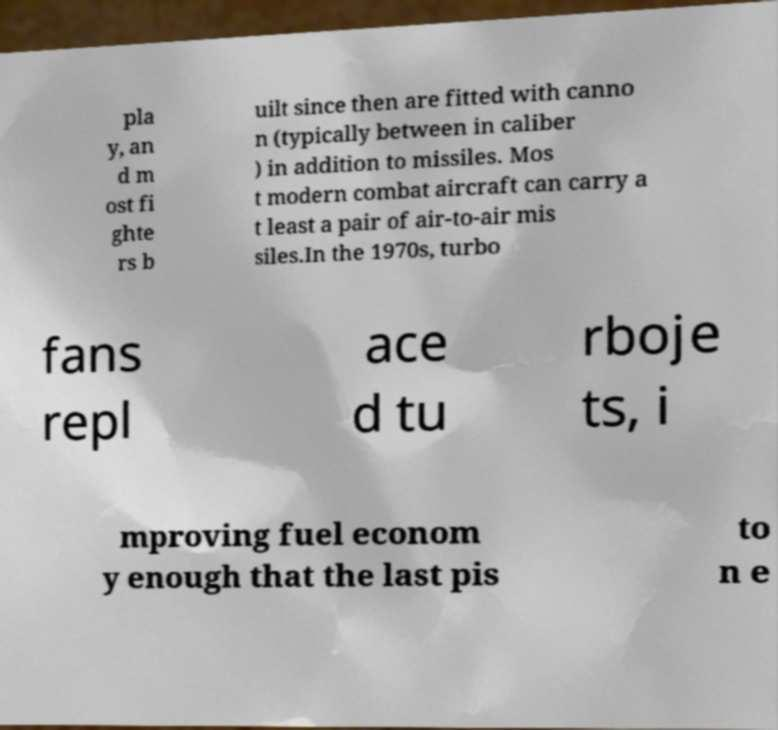Could you assist in decoding the text presented in this image and type it out clearly? pla y, an d m ost fi ghte rs b uilt since then are fitted with canno n (typically between in caliber ) in addition to missiles. Mos t modern combat aircraft can carry a t least a pair of air-to-air mis siles.In the 1970s, turbo fans repl ace d tu rboje ts, i mproving fuel econom y enough that the last pis to n e 